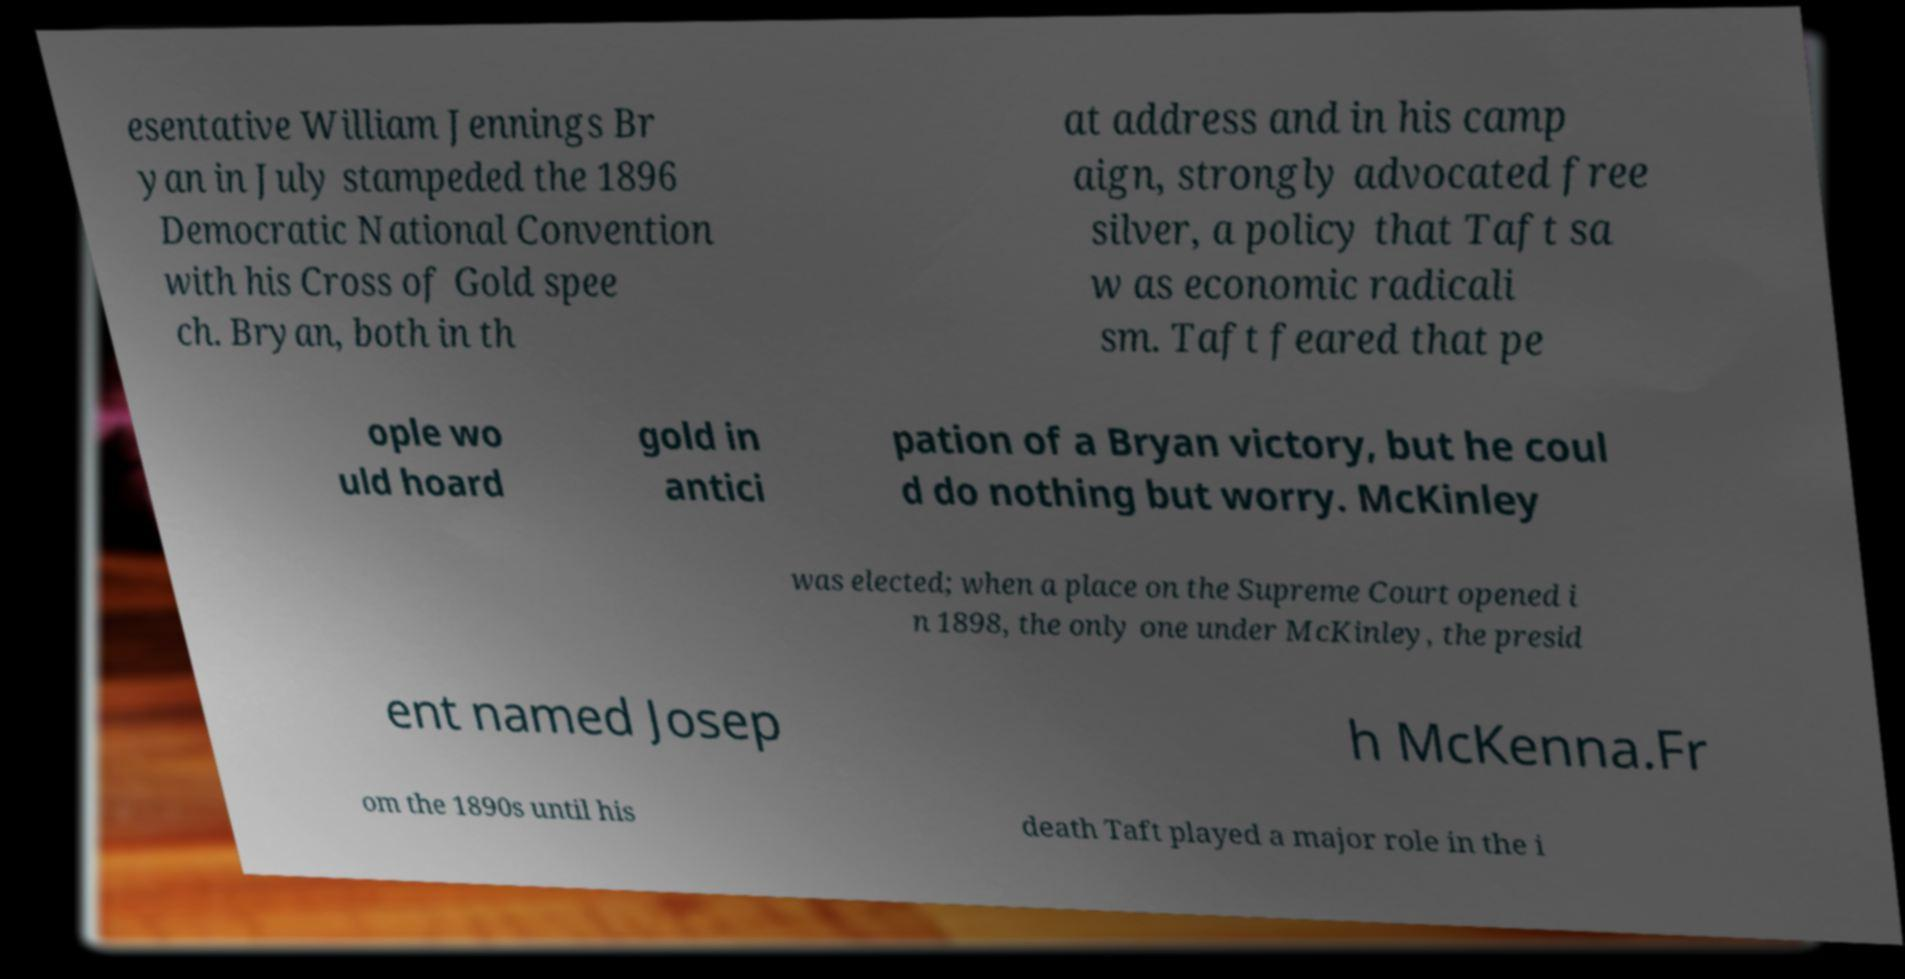What messages or text are displayed in this image? I need them in a readable, typed format. esentative William Jennings Br yan in July stampeded the 1896 Democratic National Convention with his Cross of Gold spee ch. Bryan, both in th at address and in his camp aign, strongly advocated free silver, a policy that Taft sa w as economic radicali sm. Taft feared that pe ople wo uld hoard gold in antici pation of a Bryan victory, but he coul d do nothing but worry. McKinley was elected; when a place on the Supreme Court opened i n 1898, the only one under McKinley, the presid ent named Josep h McKenna.Fr om the 1890s until his death Taft played a major role in the i 